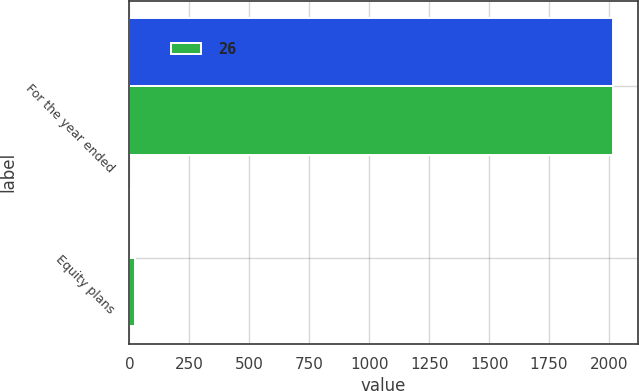Convert chart to OTSL. <chart><loc_0><loc_0><loc_500><loc_500><stacked_bar_chart><ecel><fcel>For the year ended<fcel>Equity plans<nl><fcel>nan<fcel>2019<fcel>8<nl><fcel>26<fcel>2017<fcel>21<nl></chart> 